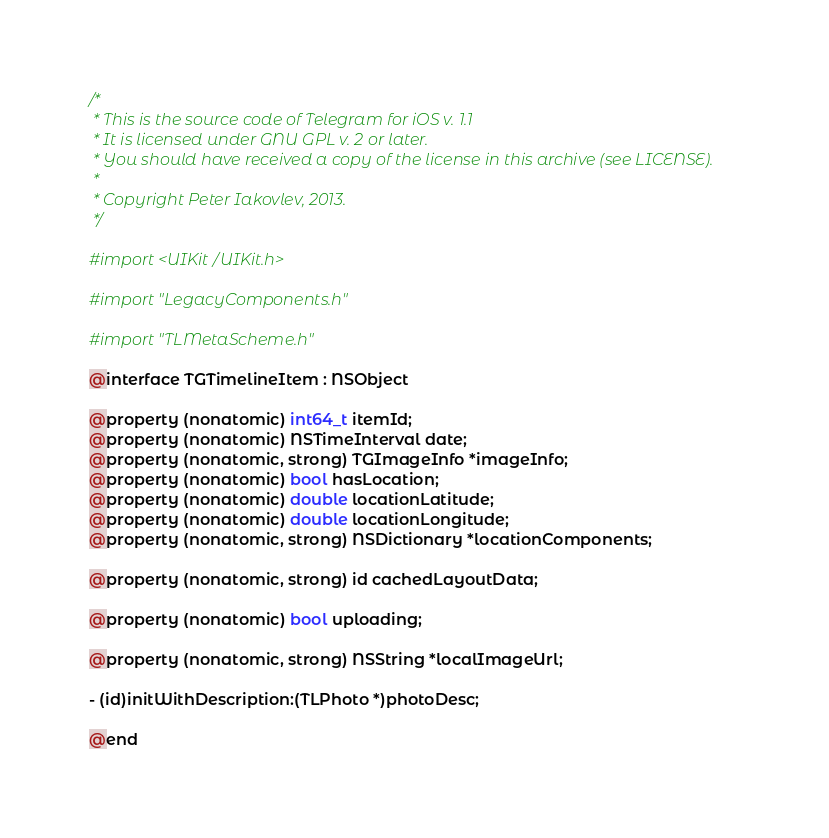<code> <loc_0><loc_0><loc_500><loc_500><_C_>/*
 * This is the source code of Telegram for iOS v. 1.1
 * It is licensed under GNU GPL v. 2 or later.
 * You should have received a copy of the license in this archive (see LICENSE).
 *
 * Copyright Peter Iakovlev, 2013.
 */

#import <UIKit/UIKit.h>

#import "LegacyComponents.h"

#import "TLMetaScheme.h"

@interface TGTimelineItem : NSObject

@property (nonatomic) int64_t itemId;
@property (nonatomic) NSTimeInterval date;
@property (nonatomic, strong) TGImageInfo *imageInfo;
@property (nonatomic) bool hasLocation;
@property (nonatomic) double locationLatitude;
@property (nonatomic) double locationLongitude;
@property (nonatomic, strong) NSDictionary *locationComponents;

@property (nonatomic, strong) id cachedLayoutData;

@property (nonatomic) bool uploading;

@property (nonatomic, strong) NSString *localImageUrl;

- (id)initWithDescription:(TLPhoto *)photoDesc;

@end
</code> 